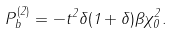Convert formula to latex. <formula><loc_0><loc_0><loc_500><loc_500>P ^ { ( 2 ) } _ { b } = - t ^ { 2 } \delta ( 1 + \delta ) \beta \chi _ { 0 } ^ { 2 } .</formula> 